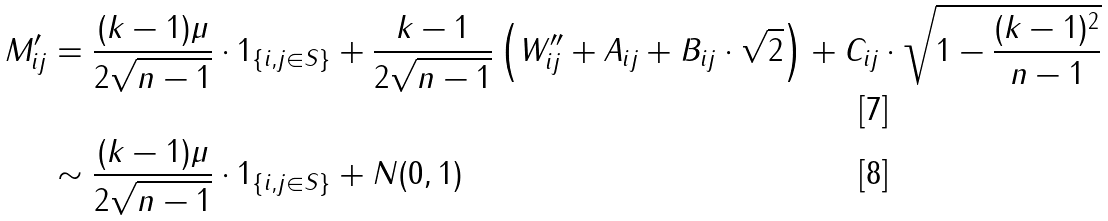Convert formula to latex. <formula><loc_0><loc_0><loc_500><loc_500>M ^ { \prime } _ { i j } & = \frac { ( k - 1 ) \mu } { 2 \sqrt { n - 1 } } \cdot 1 _ { \{ i , j \in S \} } + \frac { k - 1 } { 2 \sqrt { n - 1 } } \left ( W ^ { \prime \prime } _ { i j } + A _ { i j } + B _ { i j } \cdot \sqrt { 2 } \right ) + C _ { i j } \cdot \sqrt { 1 - \frac { ( k - 1 ) ^ { 2 } } { n - 1 } } \\ & \sim \frac { ( k - 1 ) \mu } { 2 \sqrt { n - 1 } } \cdot 1 _ { \{ i , j \in S \} } + N ( 0 , 1 )</formula> 